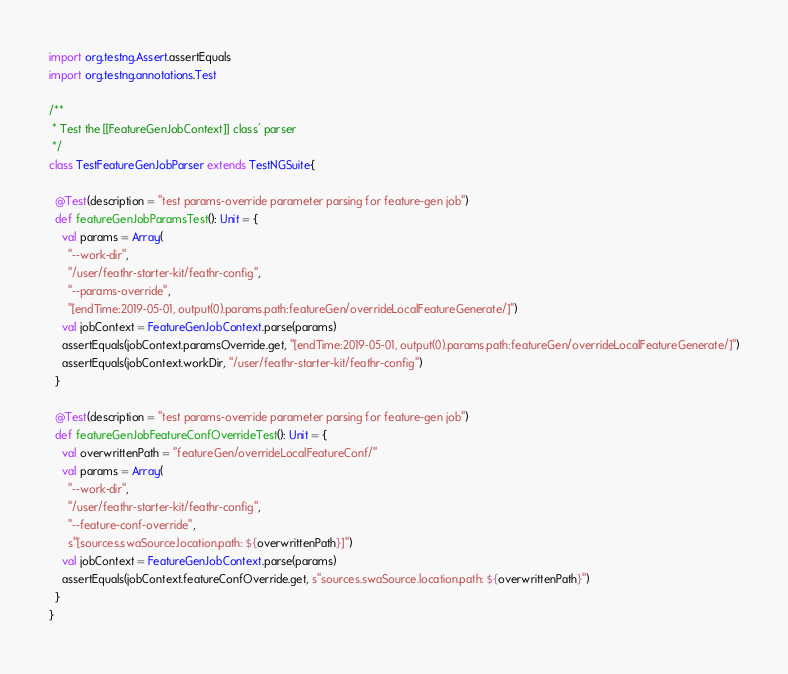<code> <loc_0><loc_0><loc_500><loc_500><_Scala_>import org.testng.Assert.assertEquals
import org.testng.annotations.Test

/**
 * Test the [[FeatureGenJobContext]] class' parser
 */
class TestFeatureGenJobParser extends TestNGSuite{

  @Test(description = "test params-override parameter parsing for feature-gen job")
  def featureGenJobParamsTest(): Unit = {
    val params = Array(
      "--work-dir",
      "/user/feathr-starter-kit/feathr-config",
      "--params-override",
      "[endTime:2019-05-01, output(0).params.path:featureGen/overrideLocalFeatureGenerate/]")
    val jobContext = FeatureGenJobContext.parse(params)
    assertEquals(jobContext.paramsOverride.get, "[endTime:2019-05-01, output(0).params.path:featureGen/overrideLocalFeatureGenerate/]")
    assertEquals(jobContext.workDir, "/user/feathr-starter-kit/feathr-config")
  }

  @Test(description = "test params-override parameter parsing for feature-gen job")
  def featureGenJobFeatureConfOverrideTest(): Unit = {
    val overwrittenPath = "featureGen/overrideLocalFeatureConf/"
    val params = Array(
      "--work-dir",
      "/user/feathr-starter-kit/feathr-config",
      "--feature-conf-override",
      s"[sources.swaSource.location.path: ${overwrittenPath}]")
    val jobContext = FeatureGenJobContext.parse(params)
    assertEquals(jobContext.featureConfOverride.get, s"sources.swaSource.location.path: ${overwrittenPath}")
  }
}
</code> 